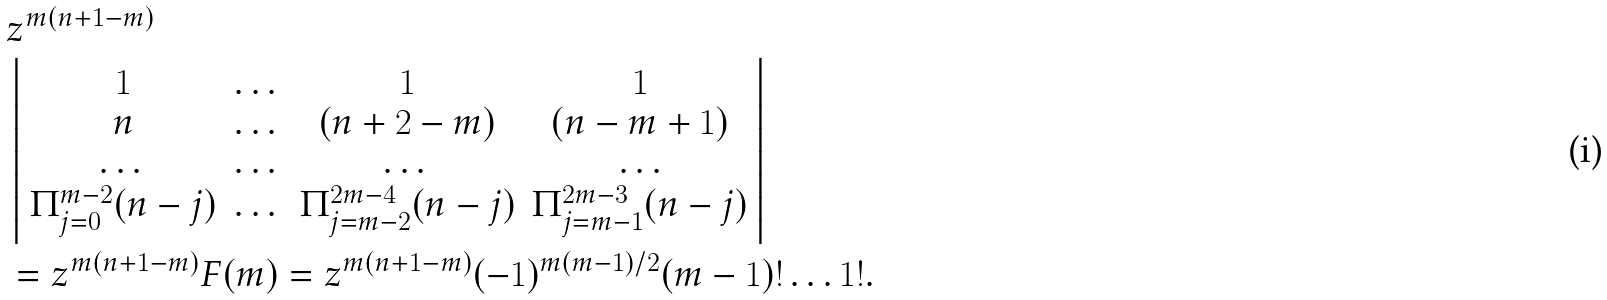Convert formula to latex. <formula><loc_0><loc_0><loc_500><loc_500>& z ^ { m ( n + 1 - m ) } \\ & \left | \begin{array} { c c c c } 1 & \dots & 1 & 1 \\ n & \dots & ( n + 2 - m ) & ( n - m + 1 ) \\ \dots & \dots & \dots & \dots \\ \Pi _ { j = 0 } ^ { m - 2 } ( n - j ) & \dots & \Pi _ { j = m - 2 } ^ { 2 m - 4 } ( n - j ) & \Pi _ { j = m - 1 } ^ { 2 m - 3 } ( n - j ) \end{array} \right | \\ & = z ^ { m ( n + 1 - m ) } F ( m ) = z ^ { m ( n + 1 - m ) } ( - 1 ) ^ { m ( m - 1 ) / 2 } ( m - 1 ) ! \dots 1 ! .</formula> 